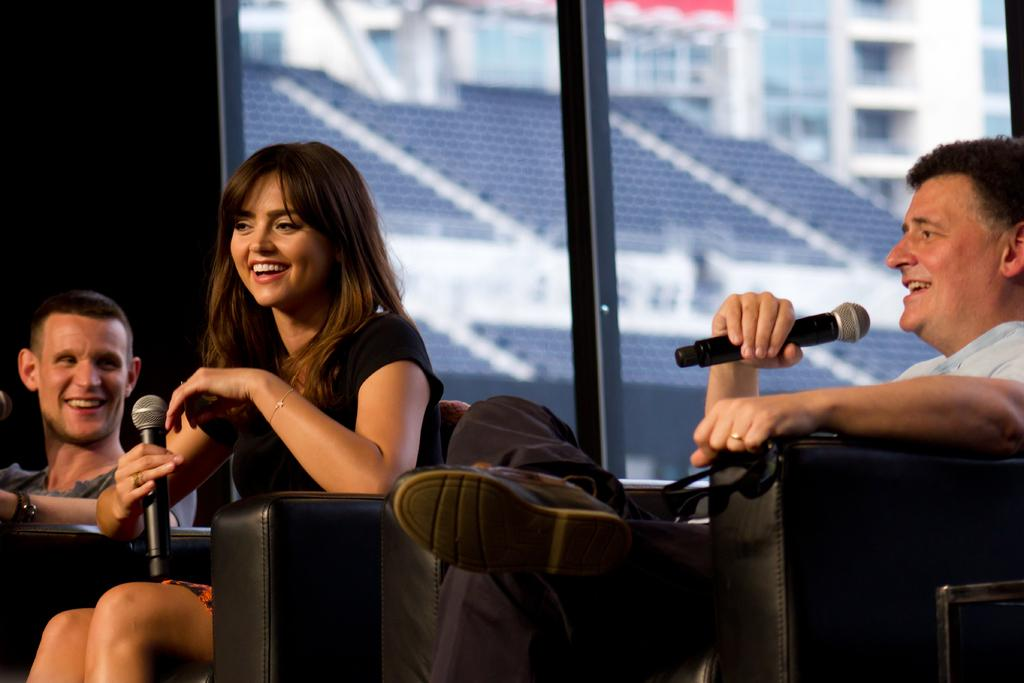How many people are in the image? There are three individuals in the image, two men and a woman. What are the expressions on their faces? All three individuals are smiling in the image. Where are the people sitting? The individuals are sitting on a couch. What can be seen in the background of the image? There is a window visible in the background. What type of goldfish can be seen swimming in the window in the image? There are no goldfish visible in the window in the image. How many pages are visible in the image? There are no pages present in the image. 